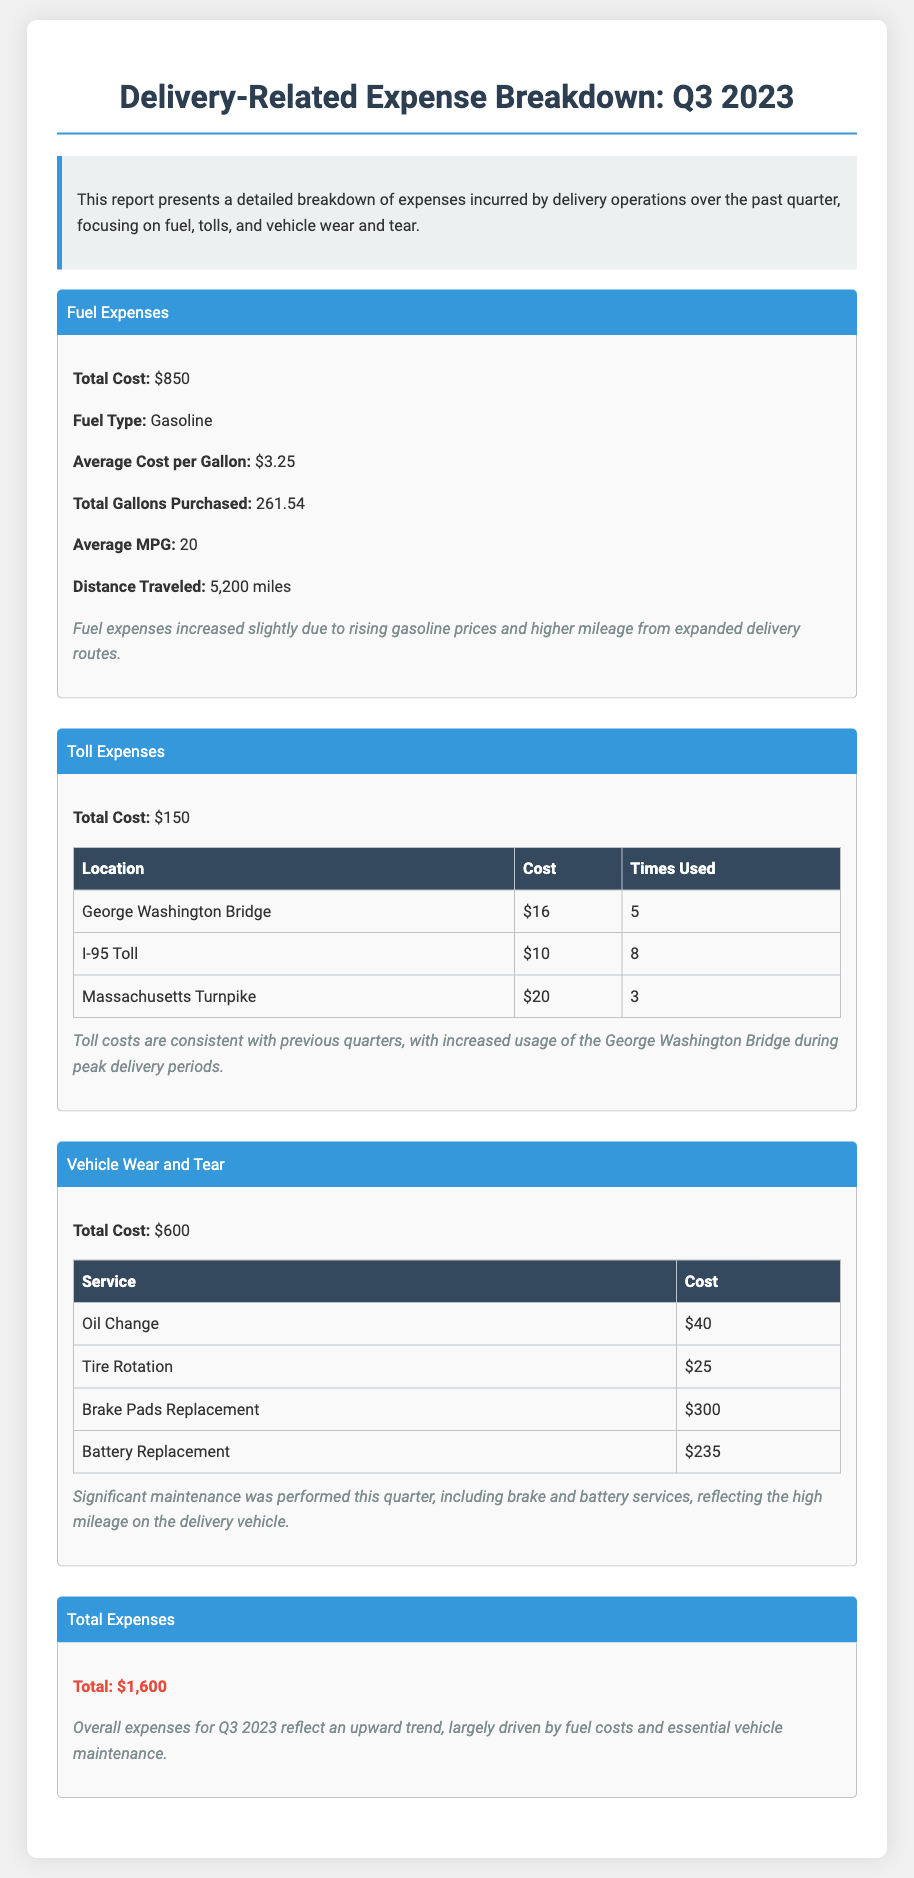What is the total fuel expense for Q3 2023? The total fuel expense is listed specifically in the Fuel Expenses section of the document, which states $850.
Answer: $850 What is the average cost per gallon of fuel? The average cost per gallon of fuel is mentioned in the Fuel Expenses section as $3.25.
Answer: $3.25 What were the total toll expenses? The total toll expenses can be found in the Toll Expenses section, where it is noted as $150.
Answer: $150 What type of fuel was used? The type of fuel used is indicated in the Fuel Expenses section, which mentions Gasoline.
Answer: Gasoline How much was spent on brake pads replacement? The cost for brake pads replacement is shown in the Vehicle Wear and Tear section as $300.
Answer: $300 What is the average mileage per gallon reported? The average MPG reported in the Fuel Expenses section is 20.
Answer: 20 What was the total number of miles traveled this quarter? The total distance traveled is outlined in the Fuel Expenses section as 5,200 miles.
Answer: 5,200 miles What was the total cost for vehicle wear and tear? The total cost for vehicle wear and tear is listed in that section, amounting to $600.
Answer: $600 What is the total expense for Q3 2023? The total expenses for Q3 2023 are consolidated at the end of the document, stating a total of $1,600.
Answer: $1,600 